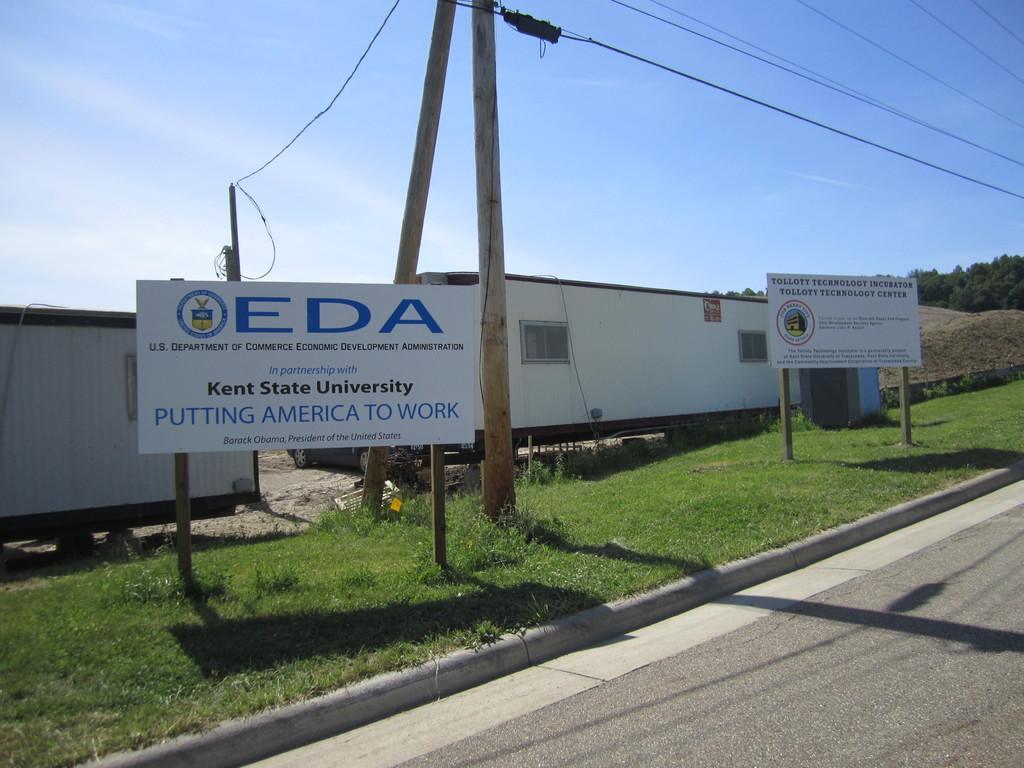Please provide a concise description of this image. In this image we can see the containers and also some information boards and poles with wires. We can also see the trees, grass and also the road. Sky is also visible. 